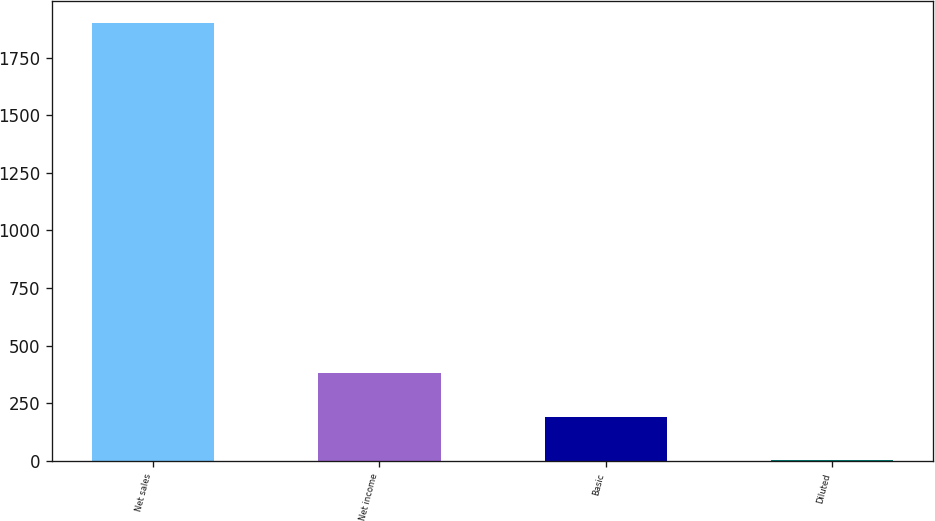<chart> <loc_0><loc_0><loc_500><loc_500><bar_chart><fcel>Net sales<fcel>Net income<fcel>Basic<fcel>Diluted<nl><fcel>1899.6<fcel>381.9<fcel>192.19<fcel>2.48<nl></chart> 